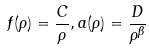Convert formula to latex. <formula><loc_0><loc_0><loc_500><loc_500>f ( \rho ) = \frac { C } { \rho } , a ( \rho ) = \frac { D } { \rho ^ { \beta } }</formula> 